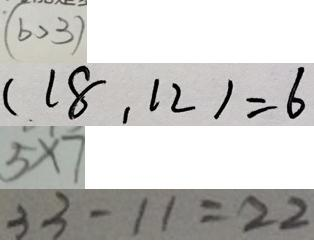Convert formula to latex. <formula><loc_0><loc_0><loc_500><loc_500>( b > 3 ) 
 ( 1 8 . 1 2 ) = 6 
 5 \times 7 
 3 3 - 1 1 = 2 2</formula> 